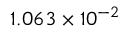Convert formula to latex. <formula><loc_0><loc_0><loc_500><loc_500>1 . 0 6 3 \times 1 0 ^ { - 2 }</formula> 